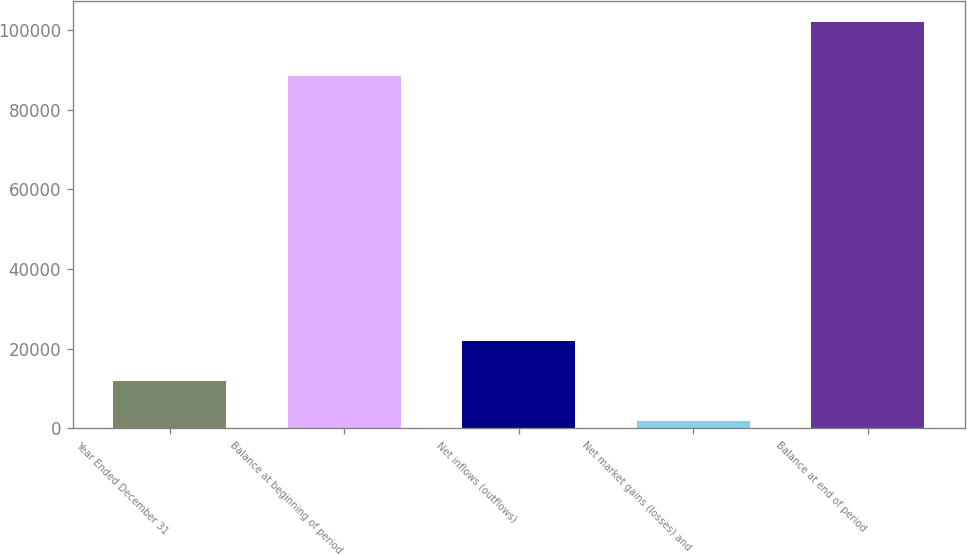Convert chart to OTSL. <chart><loc_0><loc_0><loc_500><loc_500><bar_chart><fcel>Year Ended December 31<fcel>Balance at beginning of period<fcel>Net inflows (outflows)<fcel>Net market gains (losses) and<fcel>Balance at end of period<nl><fcel>11903.2<fcel>88450<fcel>21926.4<fcel>1880<fcel>102112<nl></chart> 